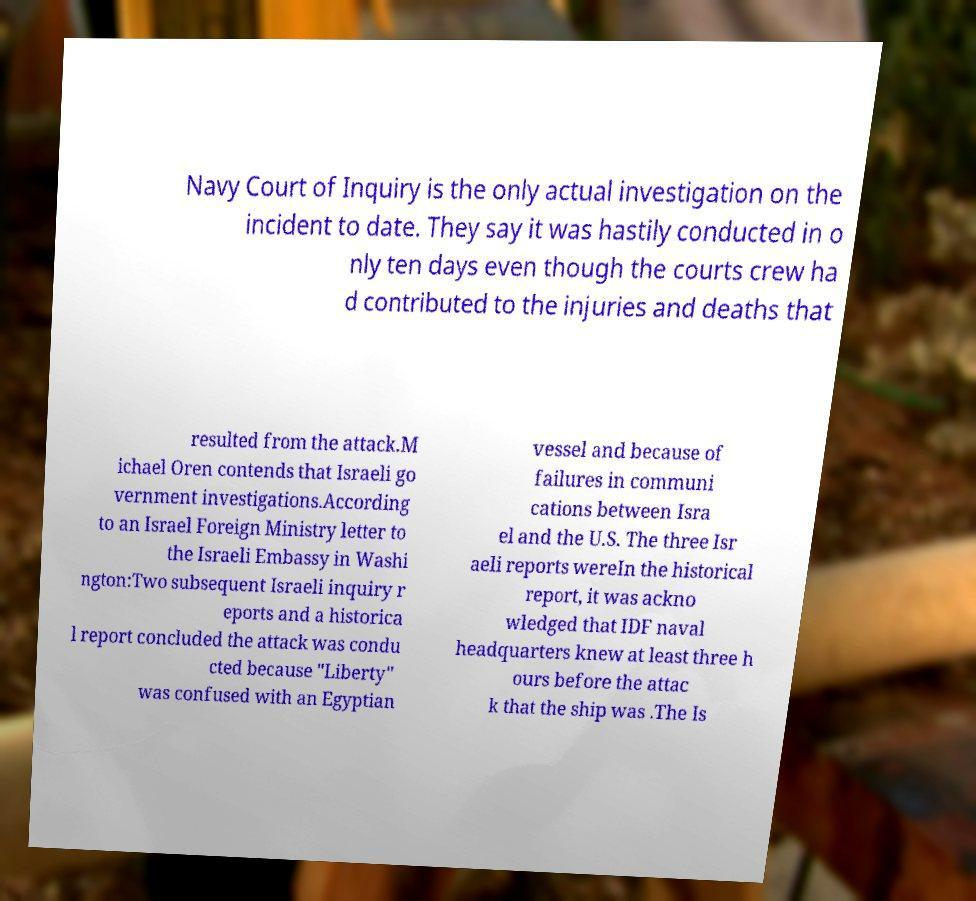Can you read and provide the text displayed in the image?This photo seems to have some interesting text. Can you extract and type it out for me? Navy Court of Inquiry is the only actual investigation on the incident to date. They say it was hastily conducted in o nly ten days even though the courts crew ha d contributed to the injuries and deaths that resulted from the attack.M ichael Oren contends that Israeli go vernment investigations.According to an Israel Foreign Ministry letter to the Israeli Embassy in Washi ngton:Two subsequent Israeli inquiry r eports and a historica l report concluded the attack was condu cted because "Liberty" was confused with an Egyptian vessel and because of failures in communi cations between Isra el and the U.S. The three Isr aeli reports wereIn the historical report, it was ackno wledged that IDF naval headquarters knew at least three h ours before the attac k that the ship was .The Is 